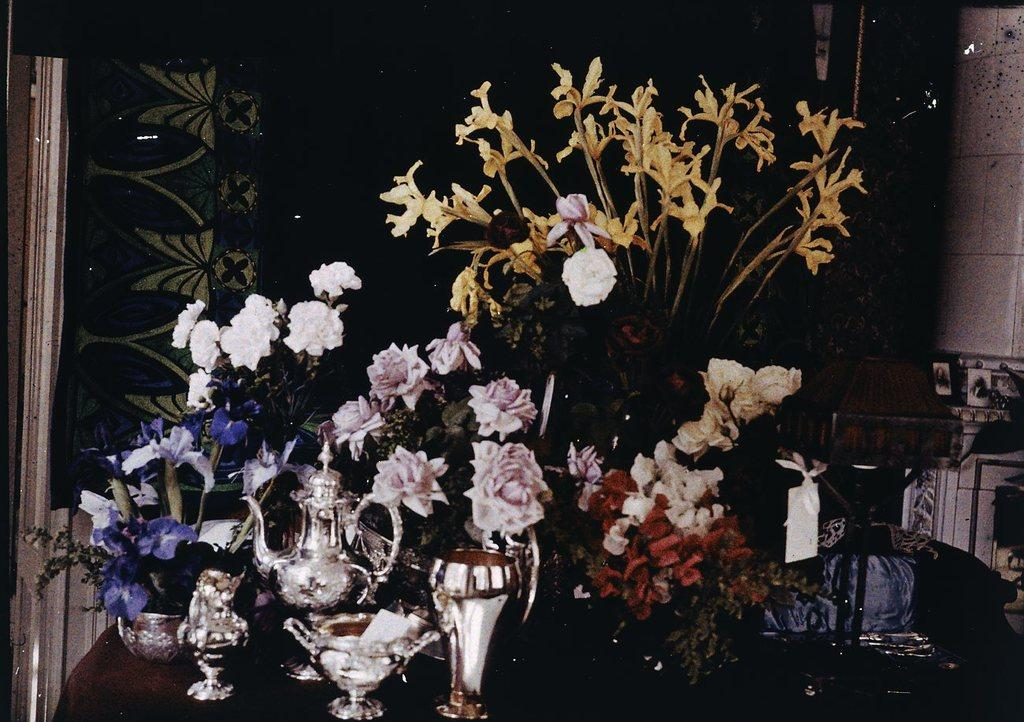What type of living organisms can be seen in the image? There are flowers and plants visible in the image. What object might be used for boiling water in the image? There is a tea kettle in the image. What can be seen on the table in the image? There are glasses on the table in the image. Where is the amusement park located in the image? There is no amusement park present in the image. Can you describe the type of van that is parked near the plants? There is no van present in the image; it only features flowers, plants, a tea kettle, and glasses on the table. 